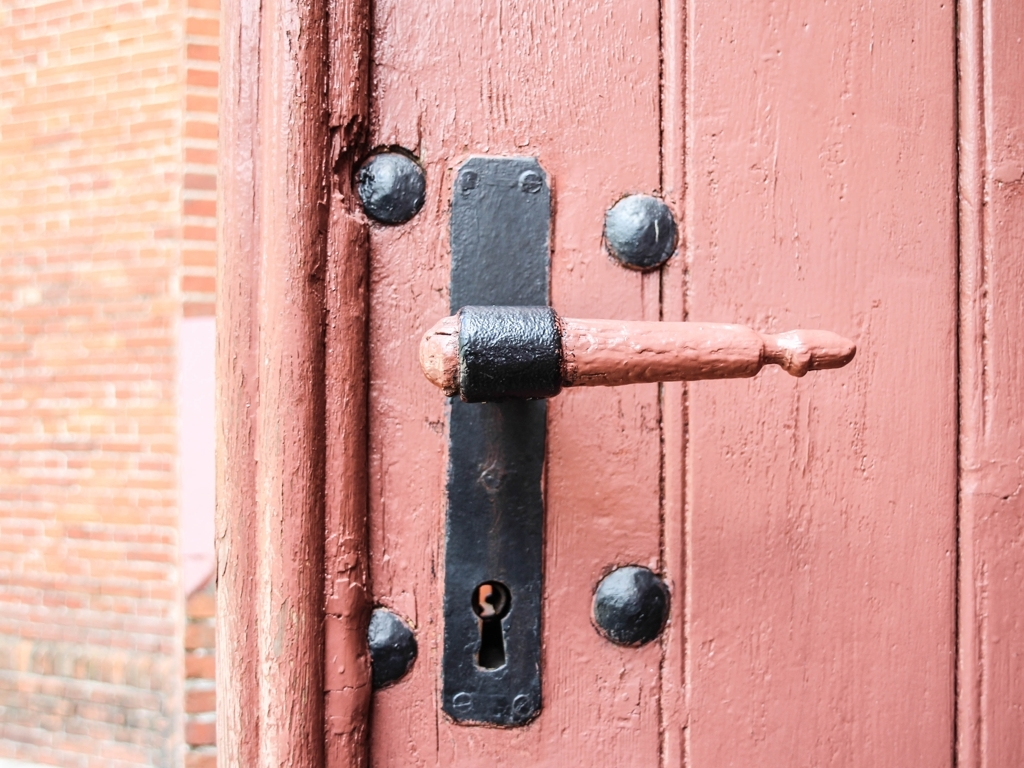Can you tell me about the condition of this door? Certainly, the door shown in the image seems to be weathered, with visible wear and a rustic charm. The paint is slightly chipped, suggesting age and usage, while the heavy-duty hardware hints at a security purpose and adds to the door's antique feel. Does the door's condition affect its functionality? While the door's aged appearance might suggest potential compromise in function, it's not possible to definitively conclude its functionality from the image alone. However, the maintained structural integrity and presence of robust hardware imply it likely remains operational. 